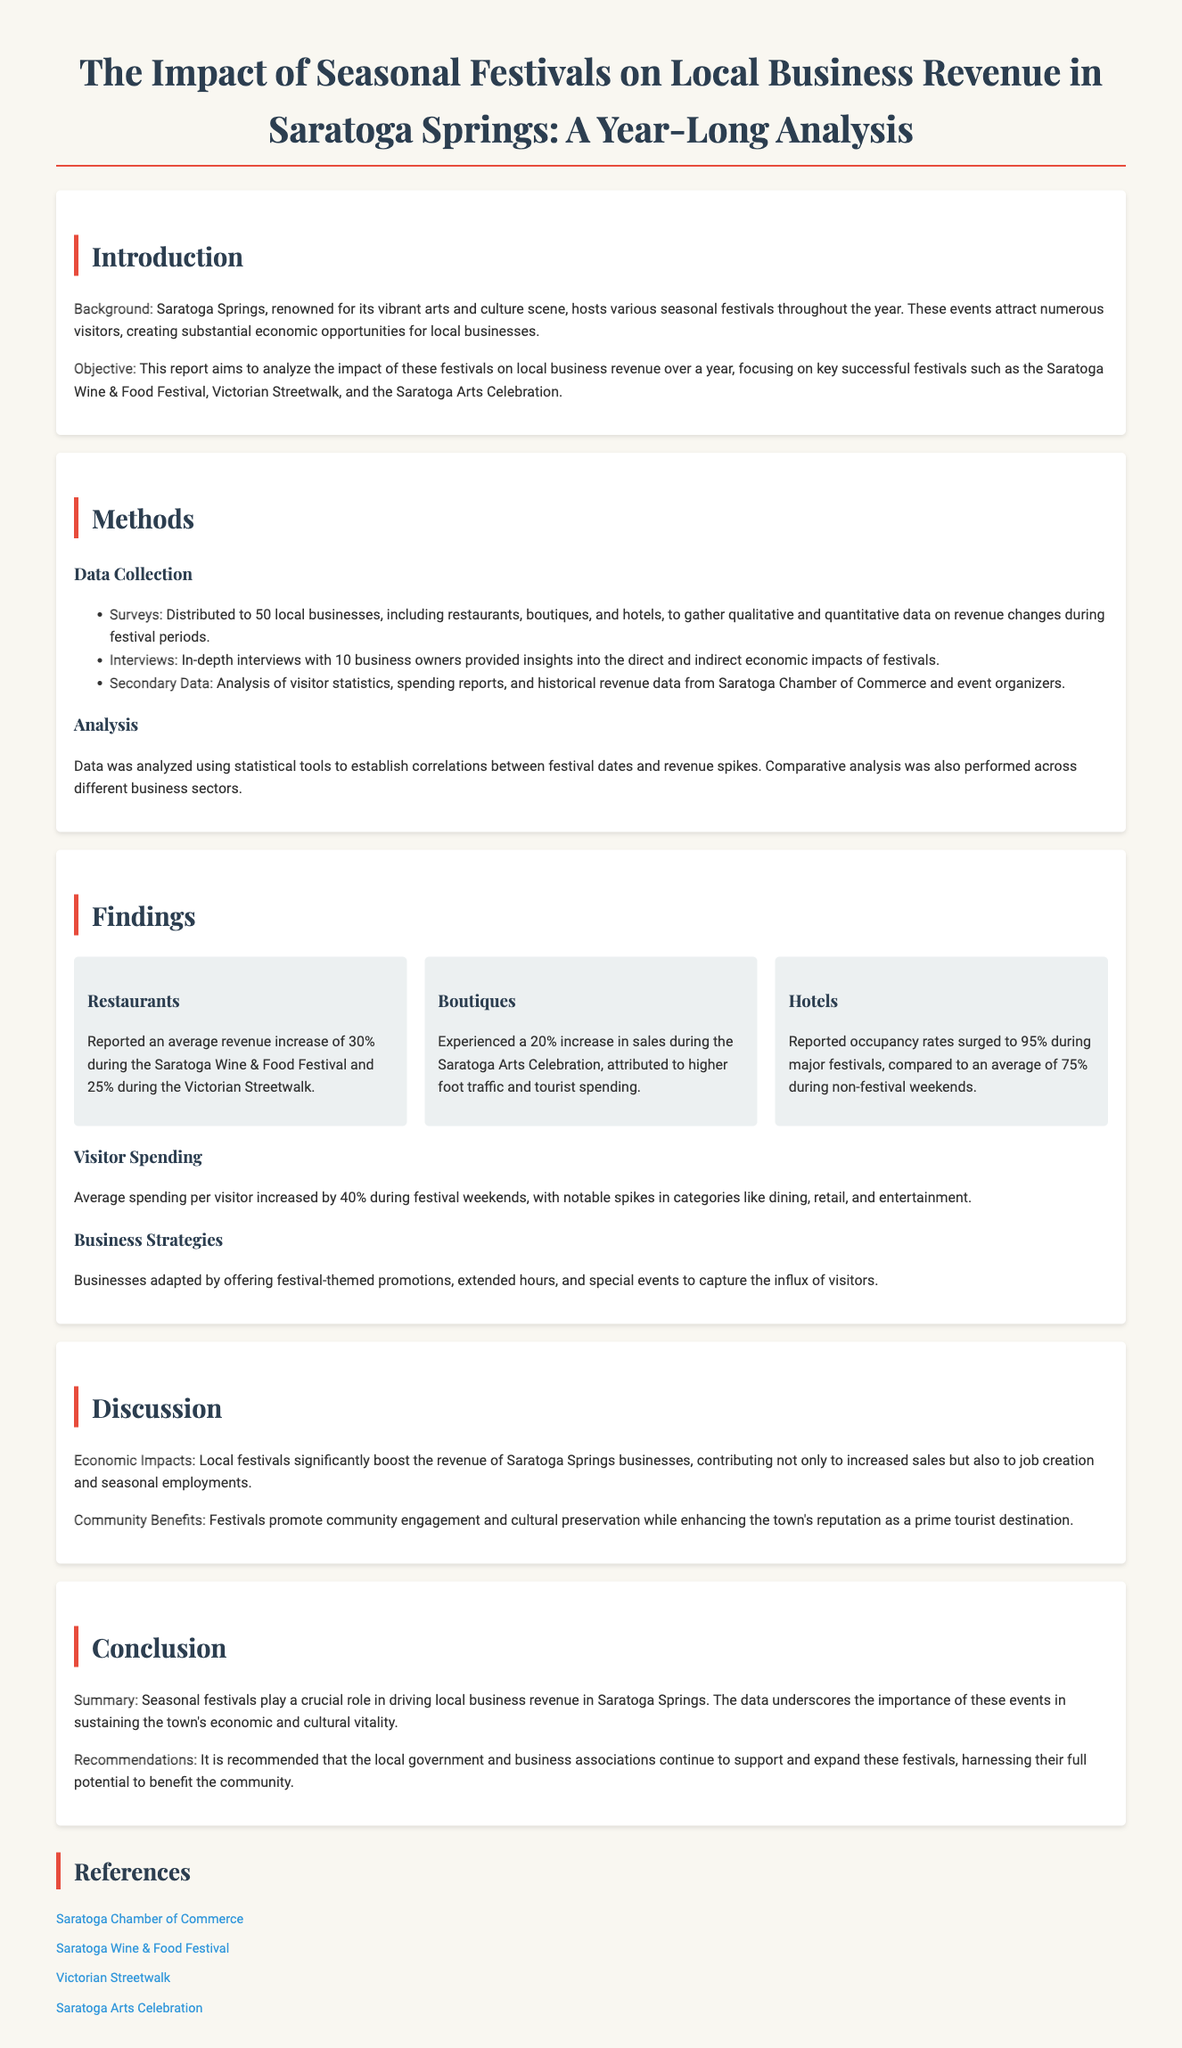What festivals were analyzed in the report? The report specifically mentions the Saratoga Wine & Food Festival, Victorian Streetwalk, and the Saratoga Arts Celebration as the key festivals analyzed.
Answer: Saratoga Wine & Food Festival, Victorian Streetwalk, Saratoga Arts Celebration What percentage increase in revenue did restaurants report during the Saratoga Wine & Food Festival? According to the findings, restaurants reported an average revenue increase of 30% during the festival.
Answer: 30% What was the average hotel occupancy rate during major festivals? The report states that hotel occupancy rates surged to 95% during major festivals.
Answer: 95% What strategy did businesses adopt during festival periods? The document highlights that businesses adapted by offering festival-themed promotions, extended hours, and special events to capture the influx of visitors.
Answer: Festival-themed promotions, extended hours, special events What was the average spending per visitor during festival weekends? The document indicates that average spending per visitor increased by 40% during festival weekends.
Answer: 40% 